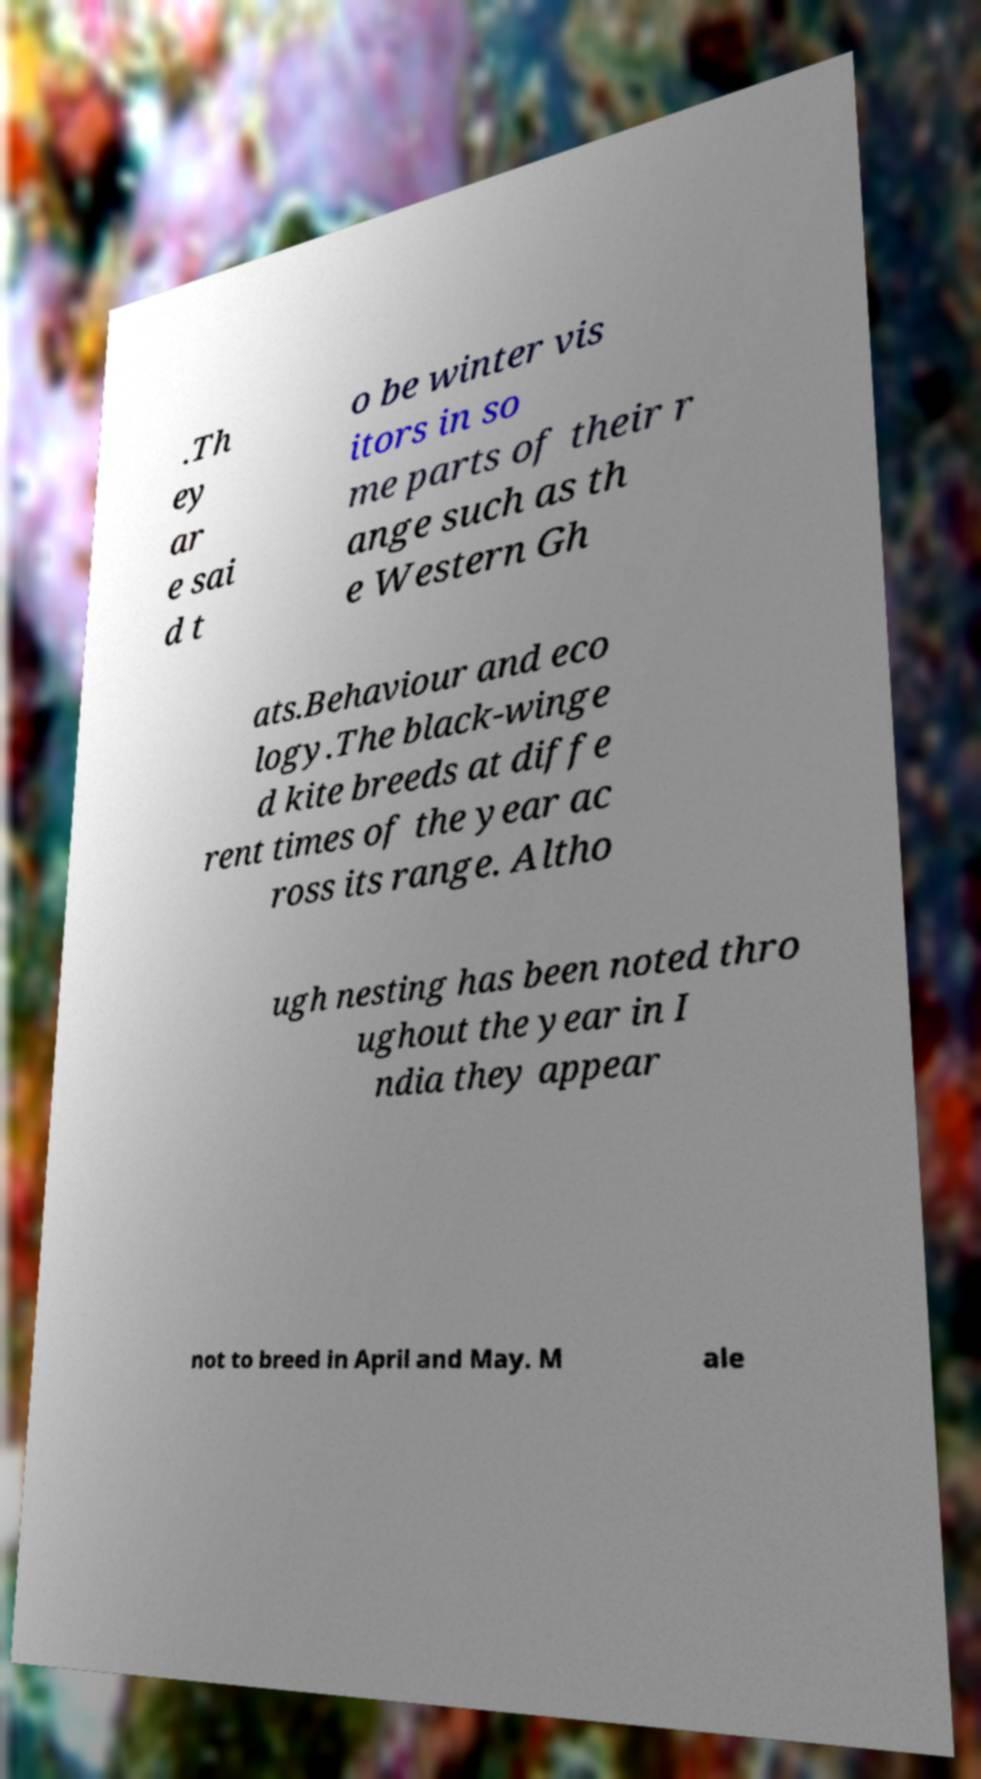There's text embedded in this image that I need extracted. Can you transcribe it verbatim? .Th ey ar e sai d t o be winter vis itors in so me parts of their r ange such as th e Western Gh ats.Behaviour and eco logy.The black-winge d kite breeds at diffe rent times of the year ac ross its range. Altho ugh nesting has been noted thro ughout the year in I ndia they appear not to breed in April and May. M ale 